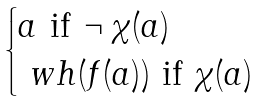Convert formula to latex. <formula><loc_0><loc_0><loc_500><loc_500>\begin{cases} a \ \text {if} \ \neg \, \chi ( a ) \\ \ w h ( f ( a ) ) \ \text {if} \ \chi ( a ) \end{cases}</formula> 